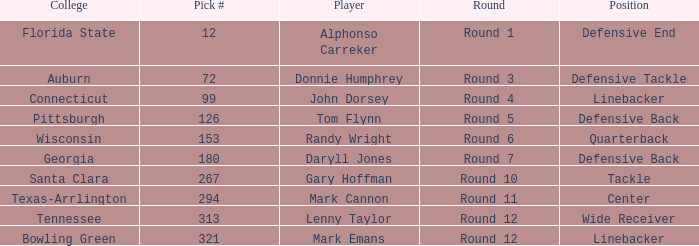In what Round was Pick #12 drafted? Round 1. 